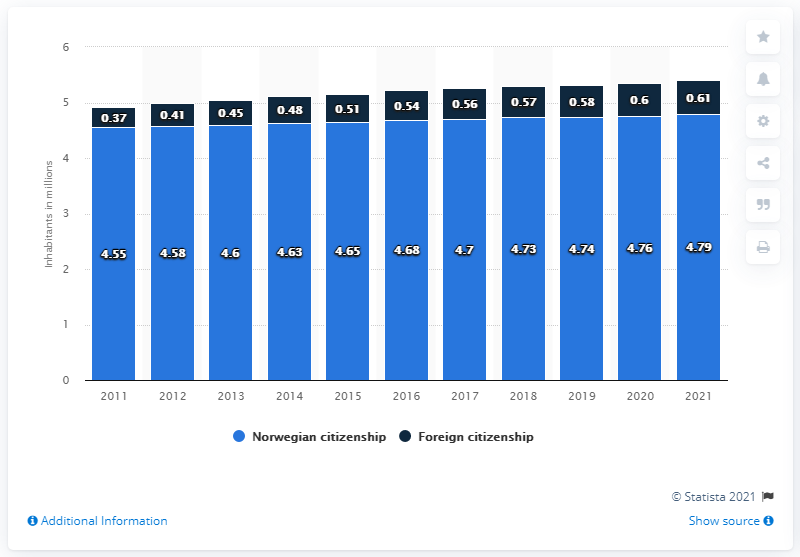Outline some significant characteristics in this image. According to data from 2021, approximately 0.61% of the population of Norway had foreign citizenship. In 2021, it is estimated that 4.79 people with Norwegian citizenship resided in Norway. 